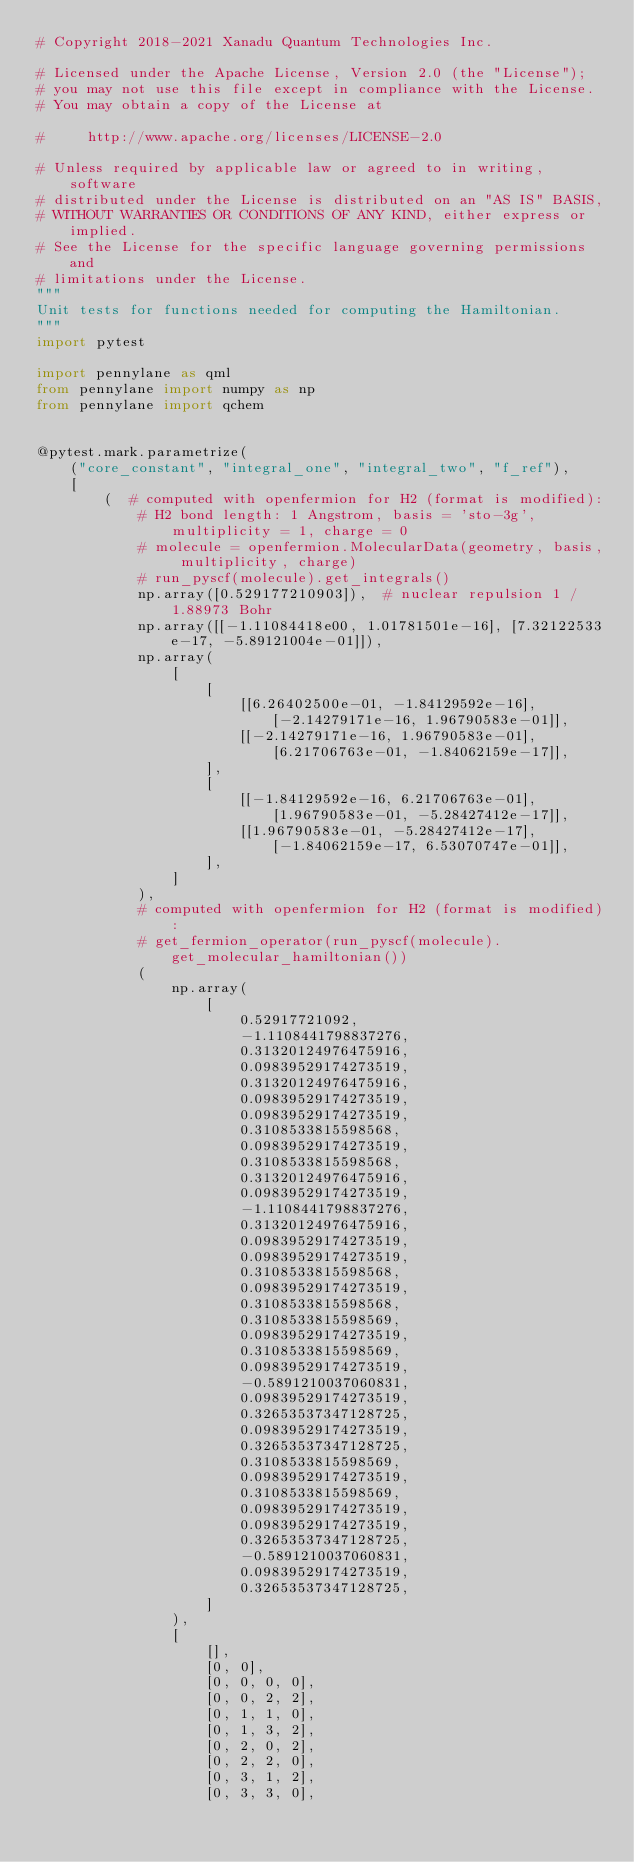<code> <loc_0><loc_0><loc_500><loc_500><_Python_># Copyright 2018-2021 Xanadu Quantum Technologies Inc.

# Licensed under the Apache License, Version 2.0 (the "License");
# you may not use this file except in compliance with the License.
# You may obtain a copy of the License at

#     http://www.apache.org/licenses/LICENSE-2.0

# Unless required by applicable law or agreed to in writing, software
# distributed under the License is distributed on an "AS IS" BASIS,
# WITHOUT WARRANTIES OR CONDITIONS OF ANY KIND, either express or implied.
# See the License for the specific language governing permissions and
# limitations under the License.
"""
Unit tests for functions needed for computing the Hamiltonian.
"""
import pytest

import pennylane as qml
from pennylane import numpy as np
from pennylane import qchem


@pytest.mark.parametrize(
    ("core_constant", "integral_one", "integral_two", "f_ref"),
    [
        (  # computed with openfermion for H2 (format is modified):
            # H2 bond length: 1 Angstrom, basis = 'sto-3g', multiplicity = 1, charge = 0
            # molecule = openfermion.MolecularData(geometry, basis, multiplicity, charge)
            # run_pyscf(molecule).get_integrals()
            np.array([0.529177210903]),  # nuclear repulsion 1 / 1.88973 Bohr
            np.array([[-1.11084418e00, 1.01781501e-16], [7.32122533e-17, -5.89121004e-01]]),
            np.array(
                [
                    [
                        [[6.26402500e-01, -1.84129592e-16], [-2.14279171e-16, 1.96790583e-01]],
                        [[-2.14279171e-16, 1.96790583e-01], [6.21706763e-01, -1.84062159e-17]],
                    ],
                    [
                        [[-1.84129592e-16, 6.21706763e-01], [1.96790583e-01, -5.28427412e-17]],
                        [[1.96790583e-01, -5.28427412e-17], [-1.84062159e-17, 6.53070747e-01]],
                    ],
                ]
            ),
            # computed with openfermion for H2 (format is modified):
            # get_fermion_operator(run_pyscf(molecule).get_molecular_hamiltonian())
            (
                np.array(
                    [
                        0.52917721092,
                        -1.1108441798837276,
                        0.31320124976475916,
                        0.09839529174273519,
                        0.31320124976475916,
                        0.09839529174273519,
                        0.09839529174273519,
                        0.3108533815598568,
                        0.09839529174273519,
                        0.3108533815598568,
                        0.31320124976475916,
                        0.09839529174273519,
                        -1.1108441798837276,
                        0.31320124976475916,
                        0.09839529174273519,
                        0.09839529174273519,
                        0.3108533815598568,
                        0.09839529174273519,
                        0.3108533815598568,
                        0.3108533815598569,
                        0.09839529174273519,
                        0.3108533815598569,
                        0.09839529174273519,
                        -0.5891210037060831,
                        0.09839529174273519,
                        0.32653537347128725,
                        0.09839529174273519,
                        0.32653537347128725,
                        0.3108533815598569,
                        0.09839529174273519,
                        0.3108533815598569,
                        0.09839529174273519,
                        0.09839529174273519,
                        0.32653537347128725,
                        -0.5891210037060831,
                        0.09839529174273519,
                        0.32653537347128725,
                    ]
                ),
                [
                    [],
                    [0, 0],
                    [0, 0, 0, 0],
                    [0, 0, 2, 2],
                    [0, 1, 1, 0],
                    [0, 1, 3, 2],
                    [0, 2, 0, 2],
                    [0, 2, 2, 0],
                    [0, 3, 1, 2],
                    [0, 3, 3, 0],</code> 